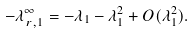<formula> <loc_0><loc_0><loc_500><loc_500>- \lambda ^ { \infty } _ { \, r , 1 } = - \lambda _ { 1 } - \lambda _ { 1 } ^ { 2 } + O ( \lambda _ { 1 } ^ { 2 } ) .</formula> 